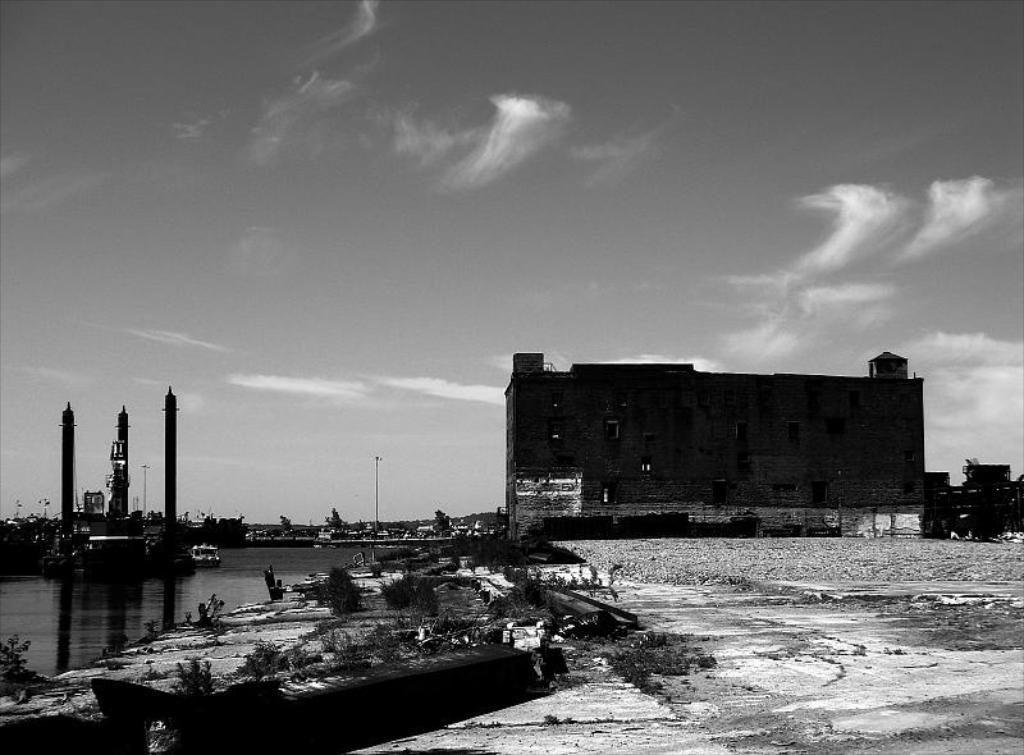Could you give a brief overview of what you see in this image? This is a black and white image. In this picture we can see the buildings, trees, poles, towers, boats, water. At the bottom of the image we can see the ground, plants. At the top of the image we can see the clouds are present in the sky. 